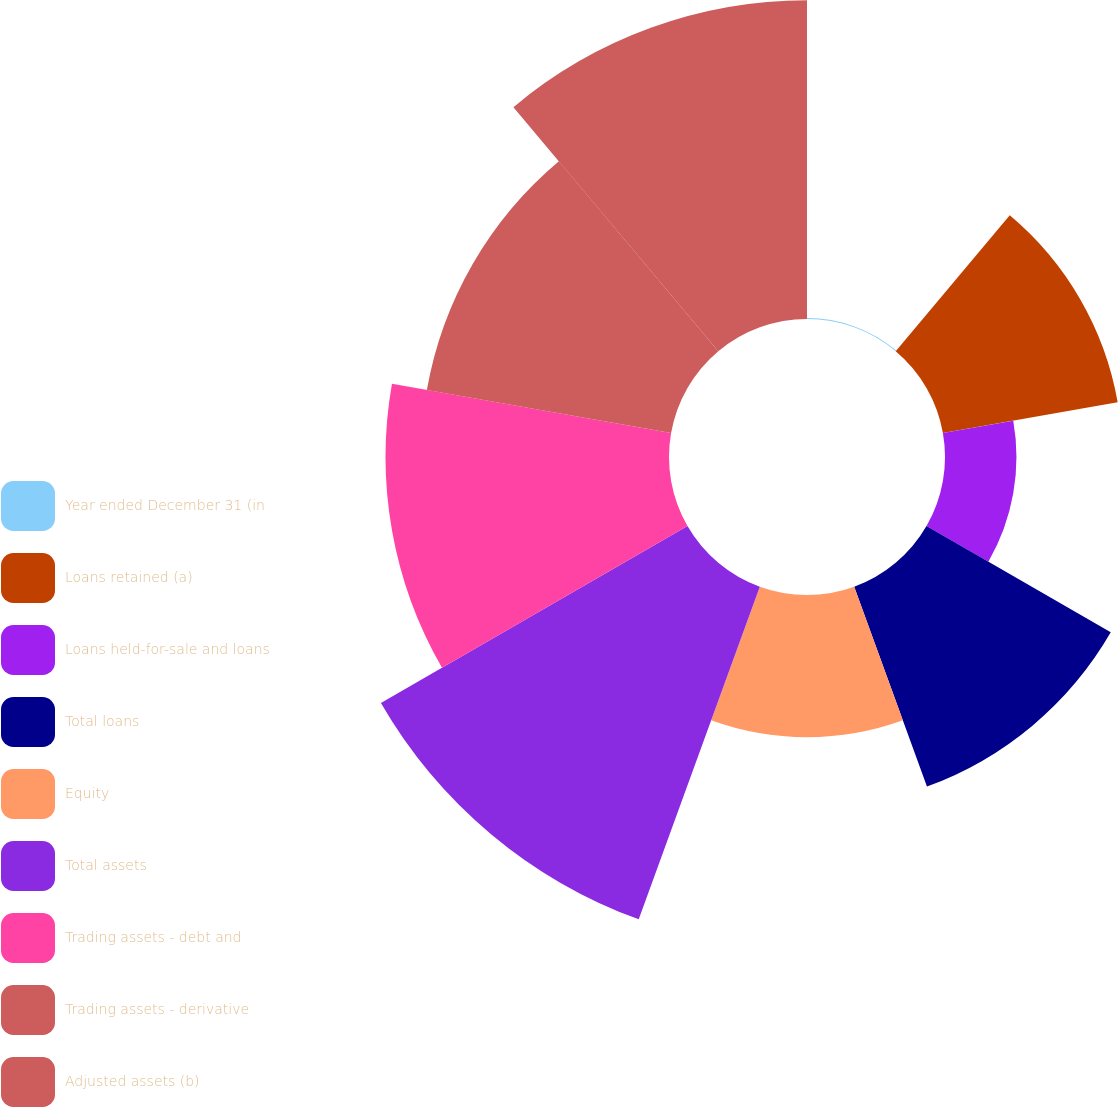Convert chart to OTSL. <chart><loc_0><loc_0><loc_500><loc_500><pie_chart><fcel>Year ended December 31 (in<fcel>Loans retained (a)<fcel>Loans held-for-sale and loans<fcel>Total loans<fcel>Equity<fcel>Total assets<fcel>Trading assets - debt and<fcel>Trading assets - derivative<fcel>Adjusted assets (b)<nl><fcel>0.05%<fcel>9.81%<fcel>3.95%<fcel>11.76%<fcel>7.86%<fcel>19.57%<fcel>15.67%<fcel>13.71%<fcel>17.62%<nl></chart> 